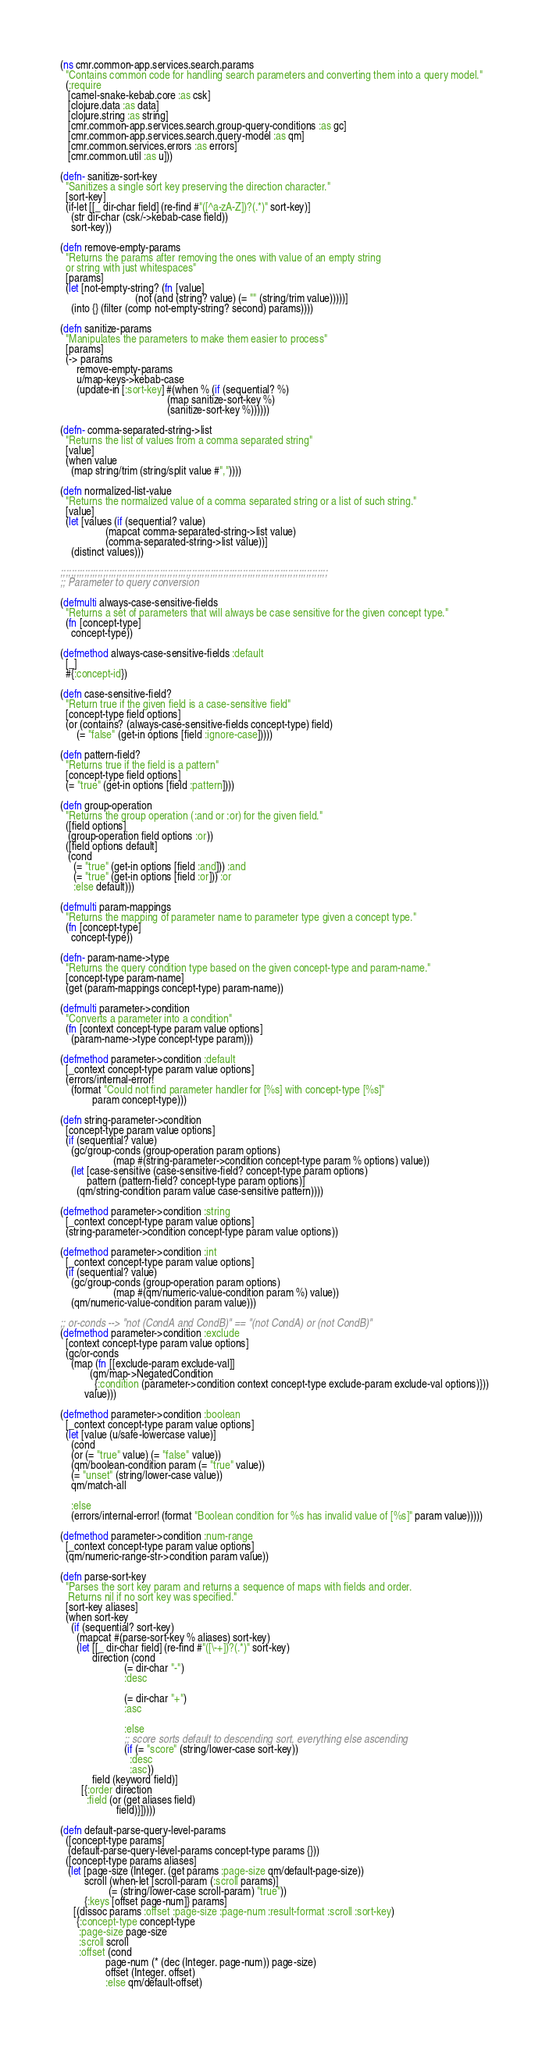Convert code to text. <code><loc_0><loc_0><loc_500><loc_500><_Clojure_>(ns cmr.common-app.services.search.params
  "Contains common code for handling search parameters and converting them into a query model."
  (:require
   [camel-snake-kebab.core :as csk]
   [clojure.data :as data]
   [clojure.string :as string]
   [cmr.common-app.services.search.group-query-conditions :as gc]
   [cmr.common-app.services.search.query-model :as qm]
   [cmr.common.services.errors :as errors]
   [cmr.common.util :as u]))

(defn- sanitize-sort-key
  "Sanitizes a single sort key preserving the direction character."
  [sort-key]
  (if-let [[_ dir-char field] (re-find #"([^a-zA-Z])?(.*)" sort-key)]
    (str dir-char (csk/->kebab-case field))
    sort-key))

(defn remove-empty-params
  "Returns the params after removing the ones with value of an empty string
  or string with just whitespaces"
  [params]
  (let [not-empty-string? (fn [value]
                            (not (and (string? value) (= "" (string/trim value)))))]
    (into {} (filter (comp not-empty-string? second) params))))

(defn sanitize-params
  "Manipulates the parameters to make them easier to process"
  [params]
  (-> params
      remove-empty-params
      u/map-keys->kebab-case
      (update-in [:sort-key] #(when % (if (sequential? %)
                                        (map sanitize-sort-key %)
                                        (sanitize-sort-key %))))))

(defn- comma-separated-string->list
  "Returns the list of values from a comma separated string"
  [value]
  (when value
    (map string/trim (string/split value #","))))

(defn normalized-list-value
  "Returns the normalized value of a comma separated string or a list of such string."
  [value]
  (let [values (if (sequential? value)
                 (mapcat comma-separated-string->list value)
                 (comma-separated-string->list value))]
    (distinct values)))

;;;;;;;;;;;;;;;;;;;;;;;;;;;;;;;;;;;;;;;;;;;;;;;;;;;;;;;;;;;;;;;;;;;;;;;;;;;;;;;;;;;;;;;;;;;;;;;;;;;;
;; Parameter to query conversion

(defmulti always-case-sensitive-fields
  "Returns a set of parameters that will always be case sensitive for the given concept type."
  (fn [concept-type]
    concept-type))

(defmethod always-case-sensitive-fields :default
  [_]
  #{:concept-id})

(defn case-sensitive-field?
  "Return true if the given field is a case-sensitive field"
  [concept-type field options]
  (or (contains? (always-case-sensitive-fields concept-type) field)
      (= "false" (get-in options [field :ignore-case]))))

(defn pattern-field?
  "Returns true if the field is a pattern"
  [concept-type field options]
  (= "true" (get-in options [field :pattern])))

(defn group-operation
  "Returns the group operation (:and or :or) for the given field."
  ([field options]
   (group-operation field options :or))
  ([field options default]
   (cond
     (= "true" (get-in options [field :and])) :and
     (= "true" (get-in options [field :or])) :or
     :else default)))

(defmulti param-mappings
  "Returns the mapping of parameter name to parameter type given a concept type."
  (fn [concept-type]
    concept-type))

(defn- param-name->type
  "Returns the query condition type based on the given concept-type and param-name."
  [concept-type param-name]
  (get (param-mappings concept-type) param-name))

(defmulti parameter->condition
  "Converts a parameter into a condition"
  (fn [context concept-type param value options]
    (param-name->type concept-type param)))

(defmethod parameter->condition :default
  [_context concept-type param value options]
  (errors/internal-error!
    (format "Could not find parameter handler for [%s] with concept-type [%s]"
            param concept-type)))

(defn string-parameter->condition
  [concept-type param value options]
  (if (sequential? value)
    (gc/group-conds (group-operation param options)
                    (map #(string-parameter->condition concept-type param % options) value))
    (let [case-sensitive (case-sensitive-field? concept-type param options)
          pattern (pattern-field? concept-type param options)]
      (qm/string-condition param value case-sensitive pattern))))

(defmethod parameter->condition :string
  [_context concept-type param value options]
  (string-parameter->condition concept-type param value options))

(defmethod parameter->condition :int
  [_context concept-type param value options]
  (if (sequential? value)
    (gc/group-conds (group-operation param options)
                    (map #(qm/numeric-value-condition param %) value))
    (qm/numeric-value-condition param value)))

;; or-conds --> "not (CondA and CondB)" == "(not CondA) or (not CondB)"
(defmethod parameter->condition :exclude
  [context concept-type param value options]
  (gc/or-conds
    (map (fn [[exclude-param exclude-val]]
           (qm/map->NegatedCondition
             {:condition (parameter->condition context concept-type exclude-param exclude-val options)}))
         value)))

(defmethod parameter->condition :boolean
  [_context concept-type param value options]
  (let [value (u/safe-lowercase value)]
    (cond
    (or (= "true" value) (= "false" value))
    (qm/boolean-condition param (= "true" value))
    (= "unset" (string/lower-case value))
    qm/match-all

    :else
    (errors/internal-error! (format "Boolean condition for %s has invalid value of [%s]" param value)))))

(defmethod parameter->condition :num-range
  [_context concept-type param value options]
  (qm/numeric-range-str->condition param value))

(defn parse-sort-key
  "Parses the sort key param and returns a sequence of maps with fields and order.
   Returns nil if no sort key was specified."
  [sort-key aliases]
  (when sort-key
    (if (sequential? sort-key)
      (mapcat #(parse-sort-key % aliases) sort-key)
      (let [[_ dir-char field] (re-find #"([\-+])?(.*)" sort-key)
            direction (cond
                        (= dir-char "-")
                        :desc

                        (= dir-char "+")
                        :asc

                        :else
                        ;; score sorts default to descending sort, everything else ascending
                        (if (= "score" (string/lower-case sort-key))
                          :desc
                          :asc))
            field (keyword field)]
        [{:order direction
          :field (or (get aliases field)
                     field)}]))))

(defn default-parse-query-level-params
  ([concept-type params]
   (default-parse-query-level-params concept-type params {}))
  ([concept-type params aliases]
   (let [page-size (Integer. (get params :page-size qm/default-page-size))
         scroll (when-let [scroll-param (:scroll params)]
                  (= (string/lower-case scroll-param) "true"))
         {:keys [offset page-num]} params]
     [(dissoc params :offset :page-size :page-num :result-format :scroll :sort-key)
      {:concept-type concept-type
       :page-size page-size
       :scroll scroll
       :offset (cond
                 page-num (* (dec (Integer. page-num)) page-size)
                 offset (Integer. offset)
                 :else qm/default-offset)</code> 